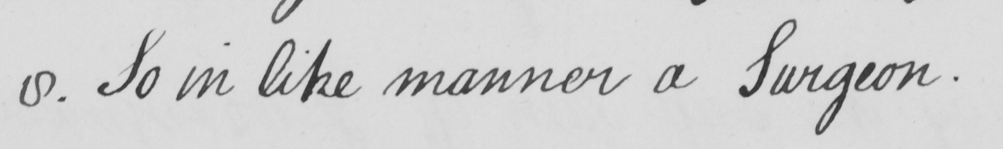What text is written in this handwritten line? 8 . So in like manner a Surgeon . 